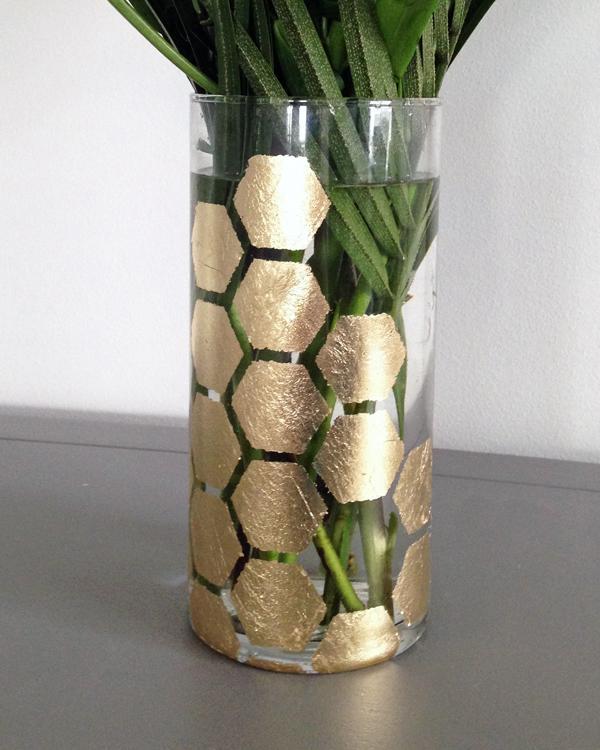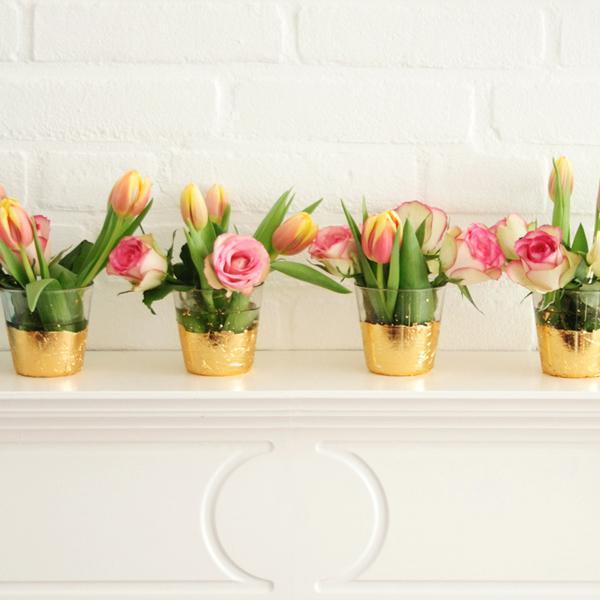The first image is the image on the left, the second image is the image on the right. Considering the images on both sides, is "Several plants sit in vases in the image on the right." valid? Answer yes or no. Yes. The first image is the image on the left, the second image is the image on the right. Analyze the images presented: Is the assertion "At least one planter has a succulent in it." valid? Answer yes or no. No. 